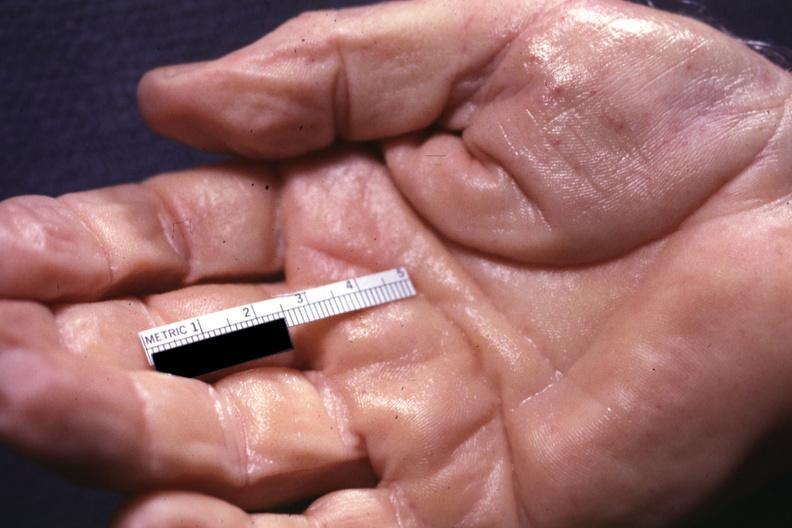s hand present?
Answer the question using a single word or phrase. Hand 